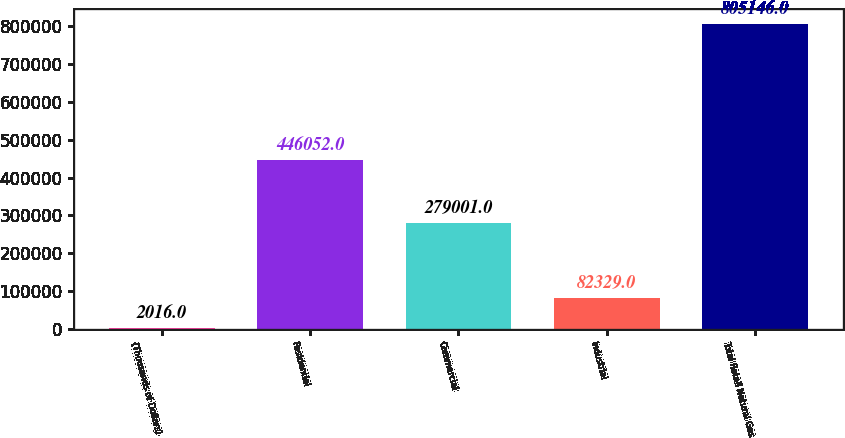Convert chart. <chart><loc_0><loc_0><loc_500><loc_500><bar_chart><fcel>(Thousands of Dollars)<fcel>Residential<fcel>Commercial<fcel>Industrial<fcel>Total Retail Natural Gas<nl><fcel>2016<fcel>446052<fcel>279001<fcel>82329<fcel>805146<nl></chart> 